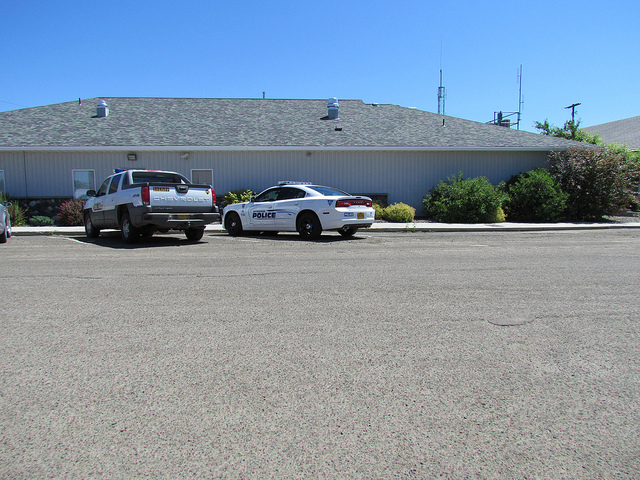Please transcribe the text information in this image. POLICE 